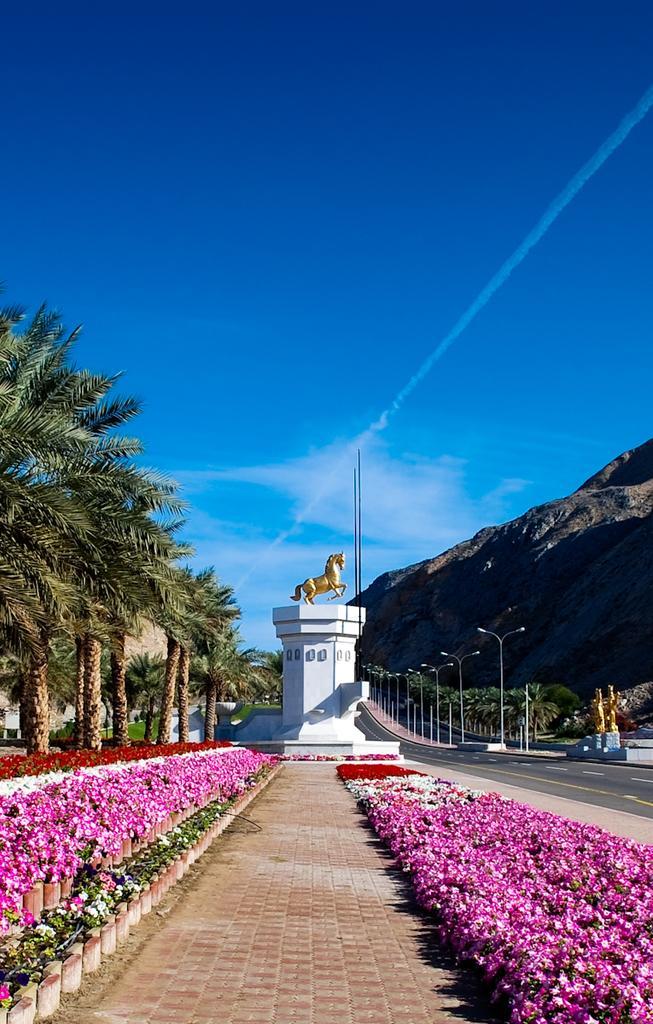Describe this image in one or two sentences. In the picture I can see pink color flowers, I can see the pathway, horse statue, trees, light poles, hills and the blue color sky with clouds in the background. 